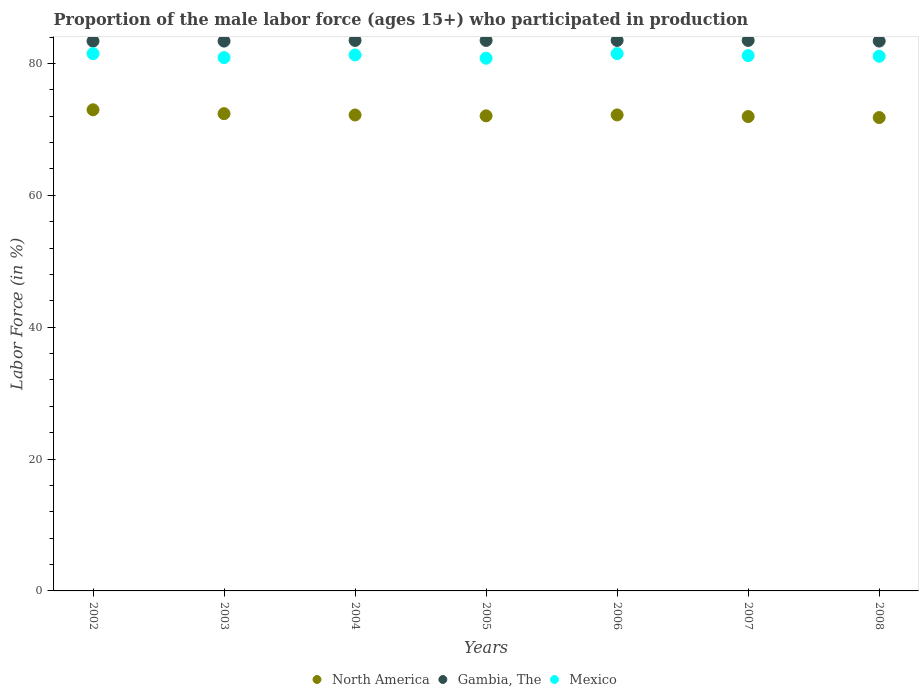How many different coloured dotlines are there?
Keep it short and to the point. 3. Is the number of dotlines equal to the number of legend labels?
Keep it short and to the point. Yes. What is the proportion of the male labor force who participated in production in Mexico in 2002?
Offer a very short reply. 81.5. Across all years, what is the maximum proportion of the male labor force who participated in production in Gambia, The?
Keep it short and to the point. 83.5. Across all years, what is the minimum proportion of the male labor force who participated in production in North America?
Provide a short and direct response. 71.8. In which year was the proportion of the male labor force who participated in production in Mexico minimum?
Offer a terse response. 2005. What is the total proportion of the male labor force who participated in production in Gambia, The in the graph?
Your answer should be compact. 584.2. What is the difference between the proportion of the male labor force who participated in production in Mexico in 2003 and that in 2005?
Keep it short and to the point. 0.1. What is the difference between the proportion of the male labor force who participated in production in Mexico in 2006 and the proportion of the male labor force who participated in production in North America in 2002?
Provide a succinct answer. 8.52. What is the average proportion of the male labor force who participated in production in Gambia, The per year?
Make the answer very short. 83.46. In the year 2007, what is the difference between the proportion of the male labor force who participated in production in North America and proportion of the male labor force who participated in production in Gambia, The?
Your response must be concise. -11.55. In how many years, is the proportion of the male labor force who participated in production in Gambia, The greater than 16 %?
Keep it short and to the point. 7. What is the ratio of the proportion of the male labor force who participated in production in Mexico in 2002 to that in 2003?
Your answer should be compact. 1.01. What is the difference between the highest and the second highest proportion of the male labor force who participated in production in Mexico?
Give a very brief answer. 0. What is the difference between the highest and the lowest proportion of the male labor force who participated in production in Gambia, The?
Provide a succinct answer. 0.1. Is the sum of the proportion of the male labor force who participated in production in North America in 2006 and 2007 greater than the maximum proportion of the male labor force who participated in production in Gambia, The across all years?
Your answer should be very brief. Yes. Is it the case that in every year, the sum of the proportion of the male labor force who participated in production in Mexico and proportion of the male labor force who participated in production in North America  is greater than the proportion of the male labor force who participated in production in Gambia, The?
Your answer should be very brief. Yes. Does the proportion of the male labor force who participated in production in North America monotonically increase over the years?
Offer a terse response. No. Is the proportion of the male labor force who participated in production in Mexico strictly less than the proportion of the male labor force who participated in production in Gambia, The over the years?
Make the answer very short. Yes. How many years are there in the graph?
Provide a succinct answer. 7. What is the title of the graph?
Provide a succinct answer. Proportion of the male labor force (ages 15+) who participated in production. Does "Congo (Democratic)" appear as one of the legend labels in the graph?
Provide a short and direct response. No. What is the label or title of the X-axis?
Ensure brevity in your answer.  Years. What is the Labor Force (in %) in North America in 2002?
Ensure brevity in your answer.  72.98. What is the Labor Force (in %) in Gambia, The in 2002?
Your answer should be compact. 83.4. What is the Labor Force (in %) of Mexico in 2002?
Provide a succinct answer. 81.5. What is the Labor Force (in %) of North America in 2003?
Make the answer very short. 72.39. What is the Labor Force (in %) of Gambia, The in 2003?
Give a very brief answer. 83.4. What is the Labor Force (in %) in Mexico in 2003?
Give a very brief answer. 80.9. What is the Labor Force (in %) of North America in 2004?
Keep it short and to the point. 72.19. What is the Labor Force (in %) of Gambia, The in 2004?
Your response must be concise. 83.5. What is the Labor Force (in %) of Mexico in 2004?
Offer a terse response. 81.3. What is the Labor Force (in %) in North America in 2005?
Keep it short and to the point. 72.06. What is the Labor Force (in %) in Gambia, The in 2005?
Make the answer very short. 83.5. What is the Labor Force (in %) in Mexico in 2005?
Ensure brevity in your answer.  80.8. What is the Labor Force (in %) in North America in 2006?
Keep it short and to the point. 72.2. What is the Labor Force (in %) of Gambia, The in 2006?
Ensure brevity in your answer.  83.5. What is the Labor Force (in %) in Mexico in 2006?
Provide a succinct answer. 81.5. What is the Labor Force (in %) in North America in 2007?
Your answer should be compact. 71.95. What is the Labor Force (in %) in Gambia, The in 2007?
Keep it short and to the point. 83.5. What is the Labor Force (in %) of Mexico in 2007?
Offer a very short reply. 81.2. What is the Labor Force (in %) of North America in 2008?
Give a very brief answer. 71.8. What is the Labor Force (in %) of Gambia, The in 2008?
Provide a short and direct response. 83.4. What is the Labor Force (in %) in Mexico in 2008?
Make the answer very short. 81.1. Across all years, what is the maximum Labor Force (in %) of North America?
Give a very brief answer. 72.98. Across all years, what is the maximum Labor Force (in %) of Gambia, The?
Give a very brief answer. 83.5. Across all years, what is the maximum Labor Force (in %) in Mexico?
Provide a short and direct response. 81.5. Across all years, what is the minimum Labor Force (in %) in North America?
Keep it short and to the point. 71.8. Across all years, what is the minimum Labor Force (in %) in Gambia, The?
Ensure brevity in your answer.  83.4. Across all years, what is the minimum Labor Force (in %) of Mexico?
Provide a succinct answer. 80.8. What is the total Labor Force (in %) of North America in the graph?
Offer a terse response. 505.58. What is the total Labor Force (in %) in Gambia, The in the graph?
Keep it short and to the point. 584.2. What is the total Labor Force (in %) of Mexico in the graph?
Provide a short and direct response. 568.3. What is the difference between the Labor Force (in %) of North America in 2002 and that in 2003?
Your answer should be very brief. 0.59. What is the difference between the Labor Force (in %) of Gambia, The in 2002 and that in 2003?
Offer a very short reply. 0. What is the difference between the Labor Force (in %) of Mexico in 2002 and that in 2003?
Your answer should be very brief. 0.6. What is the difference between the Labor Force (in %) in North America in 2002 and that in 2004?
Make the answer very short. 0.79. What is the difference between the Labor Force (in %) of Mexico in 2002 and that in 2004?
Provide a short and direct response. 0.2. What is the difference between the Labor Force (in %) of North America in 2002 and that in 2005?
Ensure brevity in your answer.  0.92. What is the difference between the Labor Force (in %) of Mexico in 2002 and that in 2005?
Make the answer very short. 0.7. What is the difference between the Labor Force (in %) of North America in 2002 and that in 2006?
Make the answer very short. 0.78. What is the difference between the Labor Force (in %) of North America in 2002 and that in 2007?
Your answer should be very brief. 1.03. What is the difference between the Labor Force (in %) in Gambia, The in 2002 and that in 2007?
Your response must be concise. -0.1. What is the difference between the Labor Force (in %) in Mexico in 2002 and that in 2007?
Ensure brevity in your answer.  0.3. What is the difference between the Labor Force (in %) of North America in 2002 and that in 2008?
Make the answer very short. 1.18. What is the difference between the Labor Force (in %) of North America in 2003 and that in 2004?
Ensure brevity in your answer.  0.2. What is the difference between the Labor Force (in %) in Mexico in 2003 and that in 2004?
Offer a very short reply. -0.4. What is the difference between the Labor Force (in %) in North America in 2003 and that in 2005?
Offer a terse response. 0.33. What is the difference between the Labor Force (in %) of North America in 2003 and that in 2006?
Give a very brief answer. 0.19. What is the difference between the Labor Force (in %) of Gambia, The in 2003 and that in 2006?
Make the answer very short. -0.1. What is the difference between the Labor Force (in %) in North America in 2003 and that in 2007?
Your answer should be compact. 0.44. What is the difference between the Labor Force (in %) of North America in 2003 and that in 2008?
Make the answer very short. 0.59. What is the difference between the Labor Force (in %) in North America in 2004 and that in 2005?
Give a very brief answer. 0.13. What is the difference between the Labor Force (in %) of Mexico in 2004 and that in 2005?
Offer a terse response. 0.5. What is the difference between the Labor Force (in %) in North America in 2004 and that in 2006?
Your answer should be very brief. -0.01. What is the difference between the Labor Force (in %) of Gambia, The in 2004 and that in 2006?
Offer a very short reply. 0. What is the difference between the Labor Force (in %) in North America in 2004 and that in 2007?
Give a very brief answer. 0.24. What is the difference between the Labor Force (in %) of North America in 2004 and that in 2008?
Offer a terse response. 0.39. What is the difference between the Labor Force (in %) of North America in 2005 and that in 2006?
Your answer should be very brief. -0.14. What is the difference between the Labor Force (in %) of Gambia, The in 2005 and that in 2006?
Ensure brevity in your answer.  0. What is the difference between the Labor Force (in %) in Mexico in 2005 and that in 2006?
Offer a terse response. -0.7. What is the difference between the Labor Force (in %) of North America in 2005 and that in 2007?
Make the answer very short. 0.11. What is the difference between the Labor Force (in %) in North America in 2005 and that in 2008?
Make the answer very short. 0.26. What is the difference between the Labor Force (in %) in North America in 2006 and that in 2007?
Ensure brevity in your answer.  0.25. What is the difference between the Labor Force (in %) in Gambia, The in 2006 and that in 2007?
Ensure brevity in your answer.  0. What is the difference between the Labor Force (in %) of North America in 2006 and that in 2008?
Your answer should be compact. 0.4. What is the difference between the Labor Force (in %) in Gambia, The in 2006 and that in 2008?
Provide a short and direct response. 0.1. What is the difference between the Labor Force (in %) of Mexico in 2006 and that in 2008?
Provide a short and direct response. 0.4. What is the difference between the Labor Force (in %) in North America in 2007 and that in 2008?
Provide a succinct answer. 0.15. What is the difference between the Labor Force (in %) in Gambia, The in 2007 and that in 2008?
Make the answer very short. 0.1. What is the difference between the Labor Force (in %) of Mexico in 2007 and that in 2008?
Your answer should be very brief. 0.1. What is the difference between the Labor Force (in %) in North America in 2002 and the Labor Force (in %) in Gambia, The in 2003?
Offer a very short reply. -10.42. What is the difference between the Labor Force (in %) in North America in 2002 and the Labor Force (in %) in Mexico in 2003?
Give a very brief answer. -7.92. What is the difference between the Labor Force (in %) of Gambia, The in 2002 and the Labor Force (in %) of Mexico in 2003?
Ensure brevity in your answer.  2.5. What is the difference between the Labor Force (in %) in North America in 2002 and the Labor Force (in %) in Gambia, The in 2004?
Make the answer very short. -10.52. What is the difference between the Labor Force (in %) of North America in 2002 and the Labor Force (in %) of Mexico in 2004?
Provide a short and direct response. -8.32. What is the difference between the Labor Force (in %) in Gambia, The in 2002 and the Labor Force (in %) in Mexico in 2004?
Keep it short and to the point. 2.1. What is the difference between the Labor Force (in %) in North America in 2002 and the Labor Force (in %) in Gambia, The in 2005?
Make the answer very short. -10.52. What is the difference between the Labor Force (in %) of North America in 2002 and the Labor Force (in %) of Mexico in 2005?
Give a very brief answer. -7.82. What is the difference between the Labor Force (in %) of Gambia, The in 2002 and the Labor Force (in %) of Mexico in 2005?
Provide a succinct answer. 2.6. What is the difference between the Labor Force (in %) of North America in 2002 and the Labor Force (in %) of Gambia, The in 2006?
Offer a terse response. -10.52. What is the difference between the Labor Force (in %) of North America in 2002 and the Labor Force (in %) of Mexico in 2006?
Ensure brevity in your answer.  -8.52. What is the difference between the Labor Force (in %) in North America in 2002 and the Labor Force (in %) in Gambia, The in 2007?
Give a very brief answer. -10.52. What is the difference between the Labor Force (in %) in North America in 2002 and the Labor Force (in %) in Mexico in 2007?
Your answer should be compact. -8.22. What is the difference between the Labor Force (in %) of North America in 2002 and the Labor Force (in %) of Gambia, The in 2008?
Make the answer very short. -10.42. What is the difference between the Labor Force (in %) in North America in 2002 and the Labor Force (in %) in Mexico in 2008?
Provide a succinct answer. -8.12. What is the difference between the Labor Force (in %) of North America in 2003 and the Labor Force (in %) of Gambia, The in 2004?
Provide a short and direct response. -11.11. What is the difference between the Labor Force (in %) in North America in 2003 and the Labor Force (in %) in Mexico in 2004?
Offer a terse response. -8.91. What is the difference between the Labor Force (in %) of Gambia, The in 2003 and the Labor Force (in %) of Mexico in 2004?
Keep it short and to the point. 2.1. What is the difference between the Labor Force (in %) of North America in 2003 and the Labor Force (in %) of Gambia, The in 2005?
Your answer should be very brief. -11.11. What is the difference between the Labor Force (in %) in North America in 2003 and the Labor Force (in %) in Mexico in 2005?
Give a very brief answer. -8.41. What is the difference between the Labor Force (in %) in Gambia, The in 2003 and the Labor Force (in %) in Mexico in 2005?
Provide a succinct answer. 2.6. What is the difference between the Labor Force (in %) in North America in 2003 and the Labor Force (in %) in Gambia, The in 2006?
Offer a very short reply. -11.11. What is the difference between the Labor Force (in %) of North America in 2003 and the Labor Force (in %) of Mexico in 2006?
Your answer should be very brief. -9.11. What is the difference between the Labor Force (in %) in North America in 2003 and the Labor Force (in %) in Gambia, The in 2007?
Your response must be concise. -11.11. What is the difference between the Labor Force (in %) in North America in 2003 and the Labor Force (in %) in Mexico in 2007?
Ensure brevity in your answer.  -8.81. What is the difference between the Labor Force (in %) in Gambia, The in 2003 and the Labor Force (in %) in Mexico in 2007?
Offer a terse response. 2.2. What is the difference between the Labor Force (in %) in North America in 2003 and the Labor Force (in %) in Gambia, The in 2008?
Provide a short and direct response. -11.01. What is the difference between the Labor Force (in %) in North America in 2003 and the Labor Force (in %) in Mexico in 2008?
Provide a short and direct response. -8.71. What is the difference between the Labor Force (in %) in North America in 2004 and the Labor Force (in %) in Gambia, The in 2005?
Give a very brief answer. -11.31. What is the difference between the Labor Force (in %) in North America in 2004 and the Labor Force (in %) in Mexico in 2005?
Provide a short and direct response. -8.61. What is the difference between the Labor Force (in %) of Gambia, The in 2004 and the Labor Force (in %) of Mexico in 2005?
Offer a very short reply. 2.7. What is the difference between the Labor Force (in %) of North America in 2004 and the Labor Force (in %) of Gambia, The in 2006?
Make the answer very short. -11.31. What is the difference between the Labor Force (in %) of North America in 2004 and the Labor Force (in %) of Mexico in 2006?
Make the answer very short. -9.31. What is the difference between the Labor Force (in %) in Gambia, The in 2004 and the Labor Force (in %) in Mexico in 2006?
Your response must be concise. 2. What is the difference between the Labor Force (in %) in North America in 2004 and the Labor Force (in %) in Gambia, The in 2007?
Your answer should be very brief. -11.31. What is the difference between the Labor Force (in %) in North America in 2004 and the Labor Force (in %) in Mexico in 2007?
Give a very brief answer. -9.01. What is the difference between the Labor Force (in %) in Gambia, The in 2004 and the Labor Force (in %) in Mexico in 2007?
Offer a very short reply. 2.3. What is the difference between the Labor Force (in %) in North America in 2004 and the Labor Force (in %) in Gambia, The in 2008?
Keep it short and to the point. -11.21. What is the difference between the Labor Force (in %) in North America in 2004 and the Labor Force (in %) in Mexico in 2008?
Your answer should be very brief. -8.91. What is the difference between the Labor Force (in %) in North America in 2005 and the Labor Force (in %) in Gambia, The in 2006?
Offer a very short reply. -11.44. What is the difference between the Labor Force (in %) of North America in 2005 and the Labor Force (in %) of Mexico in 2006?
Provide a short and direct response. -9.44. What is the difference between the Labor Force (in %) in Gambia, The in 2005 and the Labor Force (in %) in Mexico in 2006?
Offer a very short reply. 2. What is the difference between the Labor Force (in %) in North America in 2005 and the Labor Force (in %) in Gambia, The in 2007?
Your answer should be compact. -11.44. What is the difference between the Labor Force (in %) of North America in 2005 and the Labor Force (in %) of Mexico in 2007?
Provide a succinct answer. -9.14. What is the difference between the Labor Force (in %) in Gambia, The in 2005 and the Labor Force (in %) in Mexico in 2007?
Your answer should be compact. 2.3. What is the difference between the Labor Force (in %) in North America in 2005 and the Labor Force (in %) in Gambia, The in 2008?
Your answer should be compact. -11.34. What is the difference between the Labor Force (in %) of North America in 2005 and the Labor Force (in %) of Mexico in 2008?
Offer a terse response. -9.04. What is the difference between the Labor Force (in %) in Gambia, The in 2005 and the Labor Force (in %) in Mexico in 2008?
Keep it short and to the point. 2.4. What is the difference between the Labor Force (in %) of North America in 2006 and the Labor Force (in %) of Gambia, The in 2007?
Ensure brevity in your answer.  -11.3. What is the difference between the Labor Force (in %) in Gambia, The in 2006 and the Labor Force (in %) in Mexico in 2007?
Your response must be concise. 2.3. What is the difference between the Labor Force (in %) in North America in 2006 and the Labor Force (in %) in Gambia, The in 2008?
Make the answer very short. -11.2. What is the difference between the Labor Force (in %) of Gambia, The in 2006 and the Labor Force (in %) of Mexico in 2008?
Offer a very short reply. 2.4. What is the difference between the Labor Force (in %) of North America in 2007 and the Labor Force (in %) of Gambia, The in 2008?
Your response must be concise. -11.45. What is the difference between the Labor Force (in %) of North America in 2007 and the Labor Force (in %) of Mexico in 2008?
Keep it short and to the point. -9.15. What is the difference between the Labor Force (in %) of Gambia, The in 2007 and the Labor Force (in %) of Mexico in 2008?
Give a very brief answer. 2.4. What is the average Labor Force (in %) of North America per year?
Your answer should be compact. 72.23. What is the average Labor Force (in %) in Gambia, The per year?
Give a very brief answer. 83.46. What is the average Labor Force (in %) of Mexico per year?
Offer a very short reply. 81.19. In the year 2002, what is the difference between the Labor Force (in %) in North America and Labor Force (in %) in Gambia, The?
Ensure brevity in your answer.  -10.42. In the year 2002, what is the difference between the Labor Force (in %) of North America and Labor Force (in %) of Mexico?
Your answer should be very brief. -8.52. In the year 2003, what is the difference between the Labor Force (in %) of North America and Labor Force (in %) of Gambia, The?
Your answer should be compact. -11.01. In the year 2003, what is the difference between the Labor Force (in %) of North America and Labor Force (in %) of Mexico?
Offer a terse response. -8.51. In the year 2003, what is the difference between the Labor Force (in %) in Gambia, The and Labor Force (in %) in Mexico?
Provide a short and direct response. 2.5. In the year 2004, what is the difference between the Labor Force (in %) in North America and Labor Force (in %) in Gambia, The?
Offer a very short reply. -11.31. In the year 2004, what is the difference between the Labor Force (in %) of North America and Labor Force (in %) of Mexico?
Your answer should be compact. -9.11. In the year 2005, what is the difference between the Labor Force (in %) in North America and Labor Force (in %) in Gambia, The?
Offer a terse response. -11.44. In the year 2005, what is the difference between the Labor Force (in %) of North America and Labor Force (in %) of Mexico?
Your response must be concise. -8.74. In the year 2007, what is the difference between the Labor Force (in %) of North America and Labor Force (in %) of Gambia, The?
Give a very brief answer. -11.55. In the year 2007, what is the difference between the Labor Force (in %) of North America and Labor Force (in %) of Mexico?
Your answer should be very brief. -9.25. In the year 2008, what is the difference between the Labor Force (in %) in North America and Labor Force (in %) in Gambia, The?
Your answer should be compact. -11.6. In the year 2008, what is the difference between the Labor Force (in %) in North America and Labor Force (in %) in Mexico?
Provide a succinct answer. -9.3. What is the ratio of the Labor Force (in %) of Gambia, The in 2002 to that in 2003?
Your answer should be very brief. 1. What is the ratio of the Labor Force (in %) in Mexico in 2002 to that in 2003?
Your response must be concise. 1.01. What is the ratio of the Labor Force (in %) of North America in 2002 to that in 2004?
Offer a very short reply. 1.01. What is the ratio of the Labor Force (in %) of Gambia, The in 2002 to that in 2004?
Keep it short and to the point. 1. What is the ratio of the Labor Force (in %) in Mexico in 2002 to that in 2004?
Make the answer very short. 1. What is the ratio of the Labor Force (in %) of North America in 2002 to that in 2005?
Your answer should be very brief. 1.01. What is the ratio of the Labor Force (in %) of Gambia, The in 2002 to that in 2005?
Ensure brevity in your answer.  1. What is the ratio of the Labor Force (in %) in Mexico in 2002 to that in 2005?
Offer a very short reply. 1.01. What is the ratio of the Labor Force (in %) in North America in 2002 to that in 2006?
Your answer should be very brief. 1.01. What is the ratio of the Labor Force (in %) of North America in 2002 to that in 2007?
Provide a short and direct response. 1.01. What is the ratio of the Labor Force (in %) in Gambia, The in 2002 to that in 2007?
Give a very brief answer. 1. What is the ratio of the Labor Force (in %) in North America in 2002 to that in 2008?
Keep it short and to the point. 1.02. What is the ratio of the Labor Force (in %) of Mexico in 2002 to that in 2008?
Offer a terse response. 1. What is the ratio of the Labor Force (in %) in Gambia, The in 2003 to that in 2004?
Your answer should be very brief. 1. What is the ratio of the Labor Force (in %) in Mexico in 2003 to that in 2006?
Offer a very short reply. 0.99. What is the ratio of the Labor Force (in %) of North America in 2003 to that in 2007?
Ensure brevity in your answer.  1.01. What is the ratio of the Labor Force (in %) of Gambia, The in 2003 to that in 2007?
Make the answer very short. 1. What is the ratio of the Labor Force (in %) in Mexico in 2003 to that in 2007?
Provide a succinct answer. 1. What is the ratio of the Labor Force (in %) in North America in 2003 to that in 2008?
Offer a terse response. 1.01. What is the ratio of the Labor Force (in %) in Mexico in 2003 to that in 2008?
Keep it short and to the point. 1. What is the ratio of the Labor Force (in %) of Mexico in 2004 to that in 2005?
Your answer should be compact. 1.01. What is the ratio of the Labor Force (in %) in North America in 2004 to that in 2006?
Offer a terse response. 1. What is the ratio of the Labor Force (in %) in Gambia, The in 2004 to that in 2006?
Make the answer very short. 1. What is the ratio of the Labor Force (in %) in Mexico in 2004 to that in 2006?
Provide a succinct answer. 1. What is the ratio of the Labor Force (in %) in North America in 2004 to that in 2007?
Your response must be concise. 1. What is the ratio of the Labor Force (in %) in Mexico in 2004 to that in 2007?
Your answer should be very brief. 1. What is the ratio of the Labor Force (in %) in North America in 2004 to that in 2008?
Your answer should be very brief. 1.01. What is the ratio of the Labor Force (in %) in North America in 2005 to that in 2006?
Keep it short and to the point. 1. What is the ratio of the Labor Force (in %) in North America in 2005 to that in 2007?
Your answer should be very brief. 1. What is the ratio of the Labor Force (in %) of Gambia, The in 2005 to that in 2008?
Provide a succinct answer. 1. What is the ratio of the Labor Force (in %) in North America in 2006 to that in 2007?
Offer a very short reply. 1. What is the ratio of the Labor Force (in %) of Gambia, The in 2006 to that in 2007?
Offer a very short reply. 1. What is the ratio of the Labor Force (in %) in North America in 2006 to that in 2008?
Your answer should be compact. 1.01. What is the ratio of the Labor Force (in %) of Gambia, The in 2006 to that in 2008?
Ensure brevity in your answer.  1. What is the ratio of the Labor Force (in %) in Mexico in 2006 to that in 2008?
Provide a short and direct response. 1. What is the difference between the highest and the second highest Labor Force (in %) of North America?
Keep it short and to the point. 0.59. What is the difference between the highest and the lowest Labor Force (in %) in North America?
Your response must be concise. 1.18. What is the difference between the highest and the lowest Labor Force (in %) of Gambia, The?
Your answer should be very brief. 0.1. What is the difference between the highest and the lowest Labor Force (in %) in Mexico?
Provide a succinct answer. 0.7. 